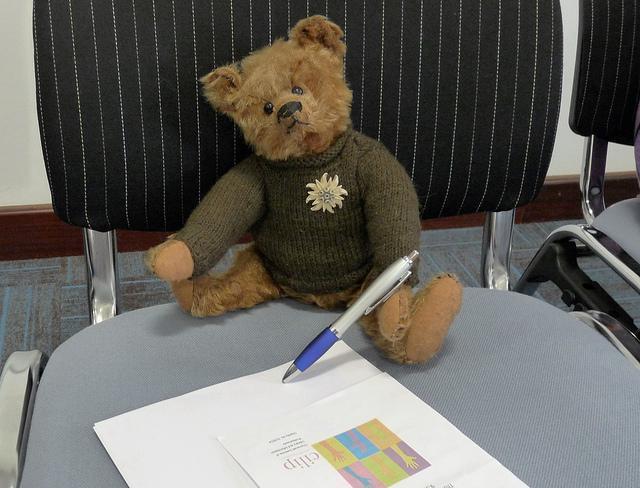How many chairs can be seen?
Give a very brief answer. 2. How many people have black shirts on?
Give a very brief answer. 0. 